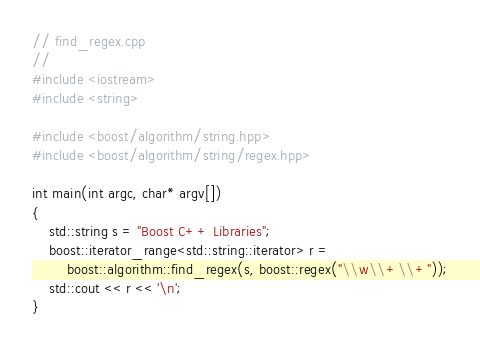<code> <loc_0><loc_0><loc_500><loc_500><_C++_>// find_regex.cpp
//
#include <iostream>
#include <string>

#include <boost/algorithm/string.hpp>
#include <boost/algorithm/string/regex.hpp>

int main(int argc, char* argv[])
{
    std::string s = "Boost C++ Libraries";
    boost::iterator_range<std::string::iterator> r =
        boost::algorithm::find_regex(s, boost::regex("\\w\\+\\+"));
    std::cout << r << '\n';
}
</code> 